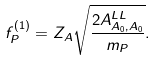Convert formula to latex. <formula><loc_0><loc_0><loc_500><loc_500>f ^ { ( 1 ) } _ { P } = Z _ { A } \sqrt { \frac { 2 A ^ { L L } _ { A _ { 0 } , A _ { 0 } } } { m _ { P } } } .</formula> 